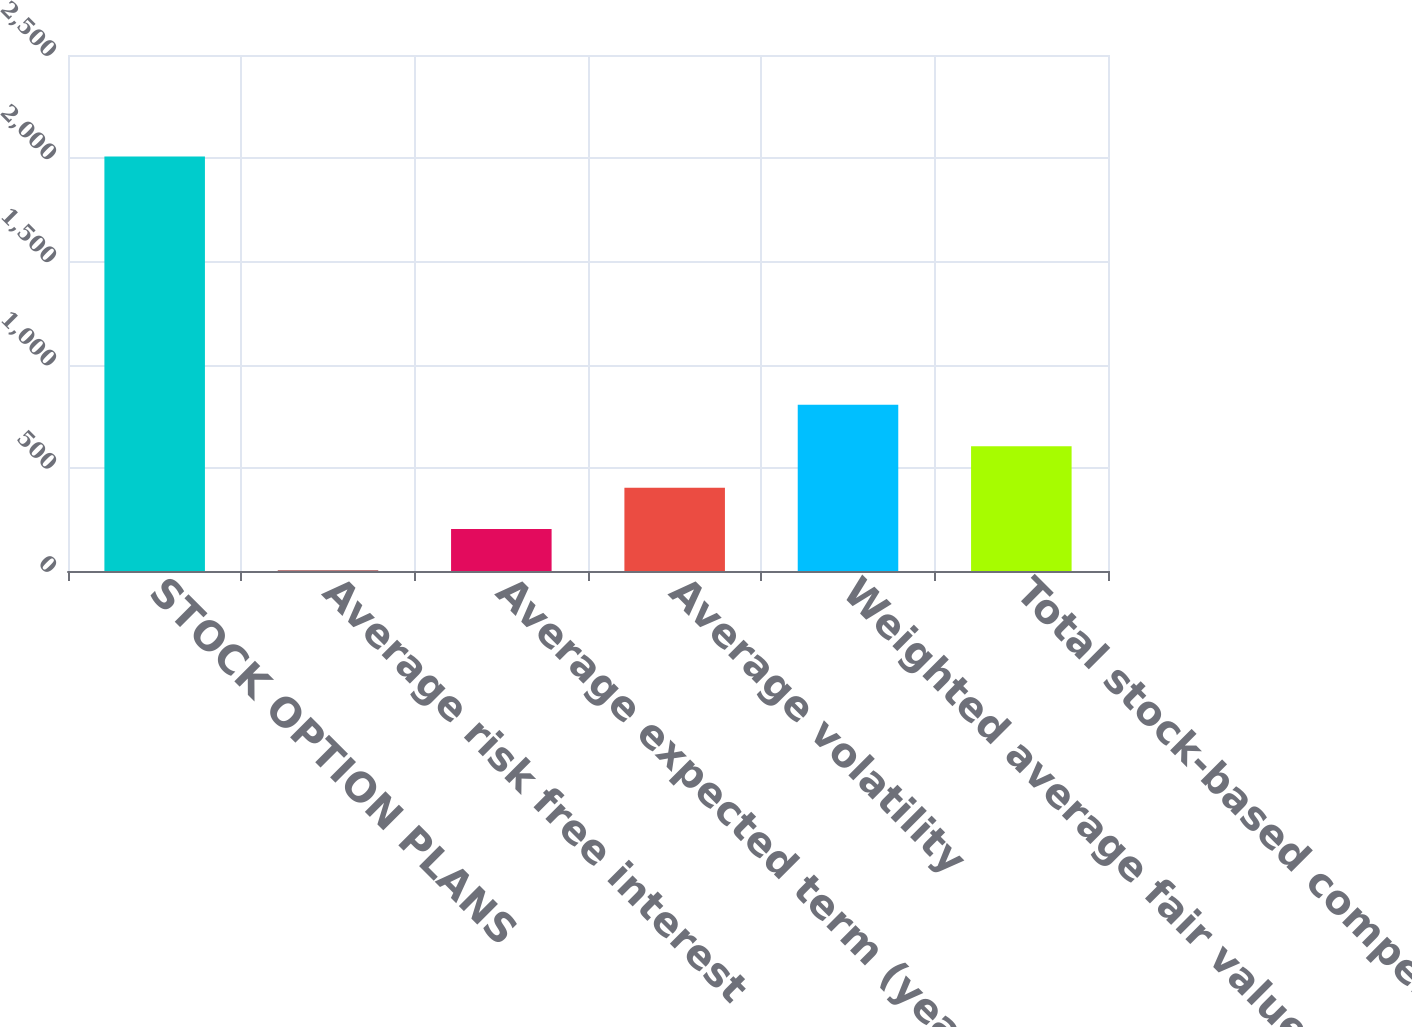<chart> <loc_0><loc_0><loc_500><loc_500><bar_chart><fcel>STOCK OPTION PLANS<fcel>Average risk free interest<fcel>Average expected term (years)<fcel>Average volatility<fcel>Weighted average fair value at<fcel>Total stock-based compensation<nl><fcel>2008<fcel>2.79<fcel>203.31<fcel>403.83<fcel>804.87<fcel>604.35<nl></chart> 